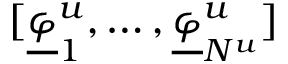<formula> <loc_0><loc_0><loc_500><loc_500>[ \underline { \varphi } _ { 1 } ^ { u } , \dots , \underline { \varphi } _ { N ^ { u } } ^ { u } ]</formula> 